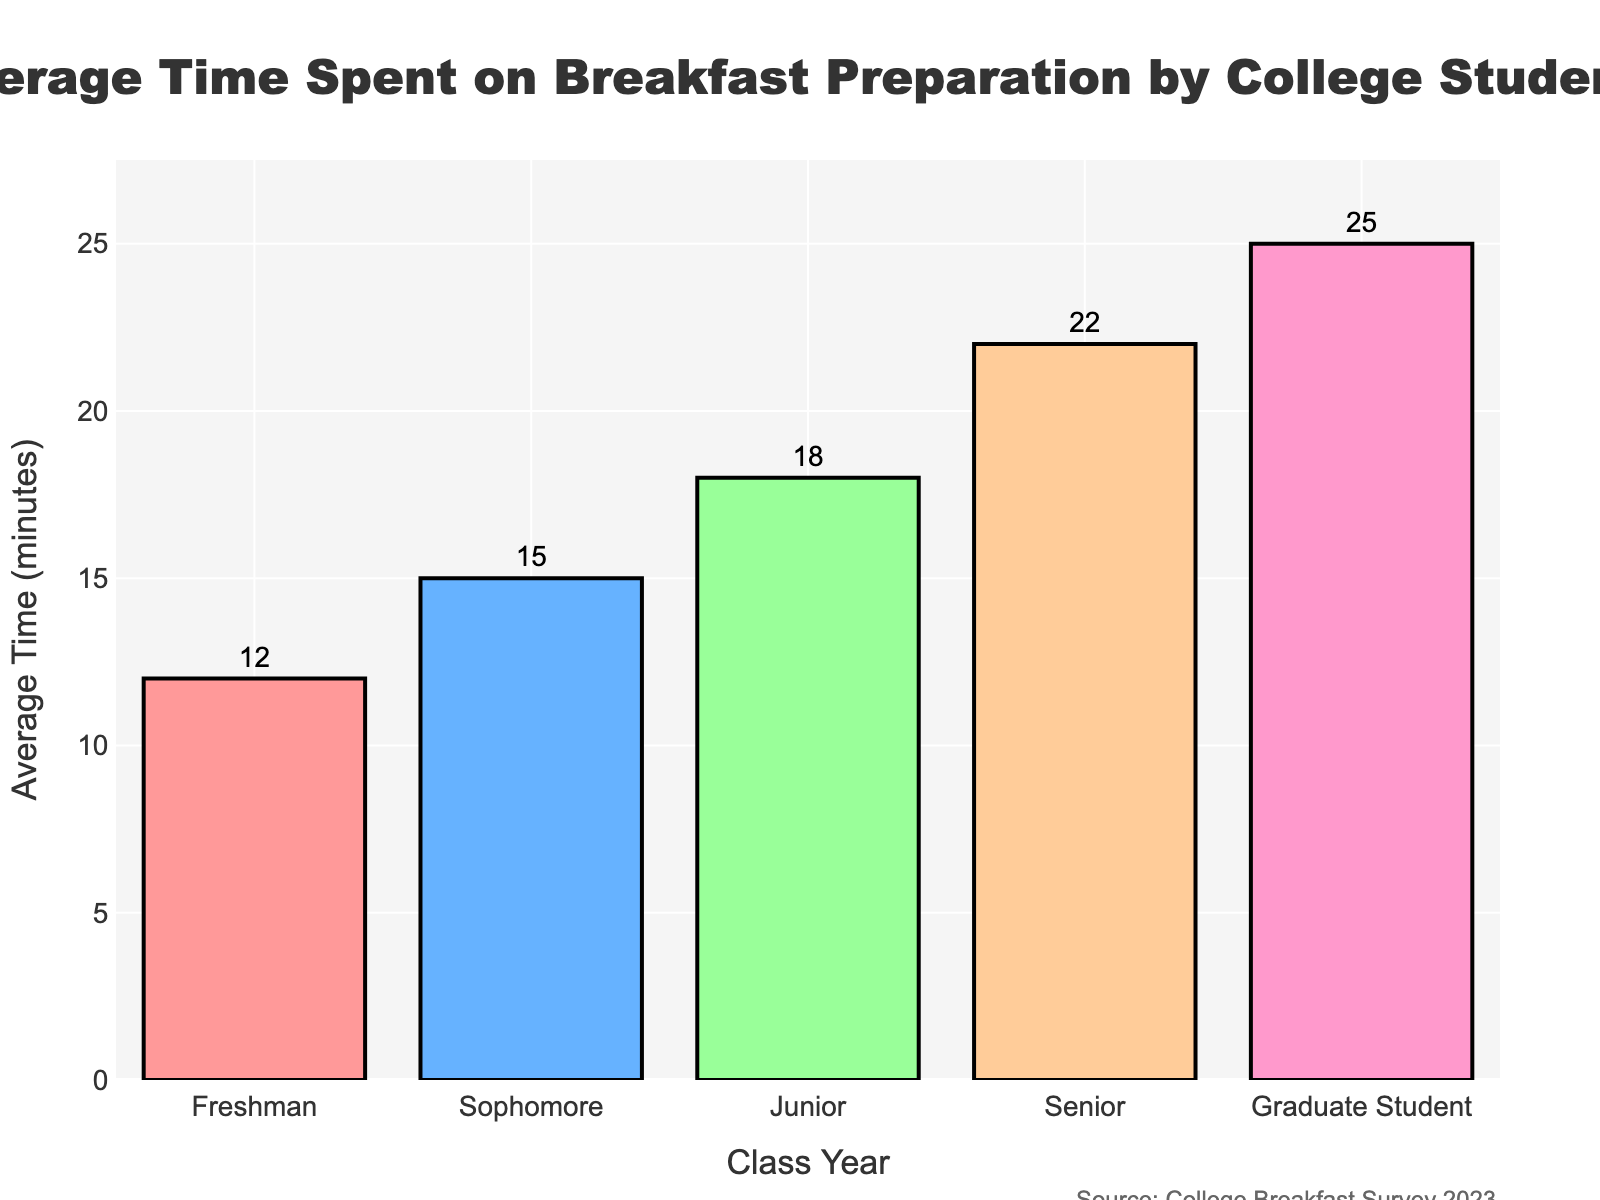What is the average time spent on breakfast preparation by freshman students? The average time spent on breakfast preparation by freshman students can be directly read from the bar representing the "Freshman" class year.
Answer: 12 minutes Which class year spends the most time on breakfast preparation? By comparing the heights of all bars, the bar representing "Graduate Student" is the tallest, indicating they spend the most time.
Answer: Graduate Student How much more time do graduate students spend on breakfast preparation compared to freshman students? Find the difference between the average times for "Graduate Student" and "Freshman": 25 minutes (Graduate Student) - 12 minutes (Freshman) = 13 minutes.
Answer: 13 minutes Which class year has the lowest average time spent on breakfast preparation, and what is that time? The bar for "Freshman" is the shortest, indicating they spend the least time, which is 12 minutes.
Answer: Freshman, 12 minutes What is the total time spent on breakfast preparation by all class years combined? Sum the average times for each class year: 12 (Freshman) + 15 (Sophomore) + 18 (Junior) + 22 (Senior) + 25 (Graduate Student) = 92 minutes.
Answer: 92 minutes How does the average time spent on breakfast preparation by seniors compare to juniors? Compare the average times: 22 minutes for seniors and 18 minutes for juniors. Seniors spend more time than juniors.
Answer: Seniors spend 4 more minutes than juniors 